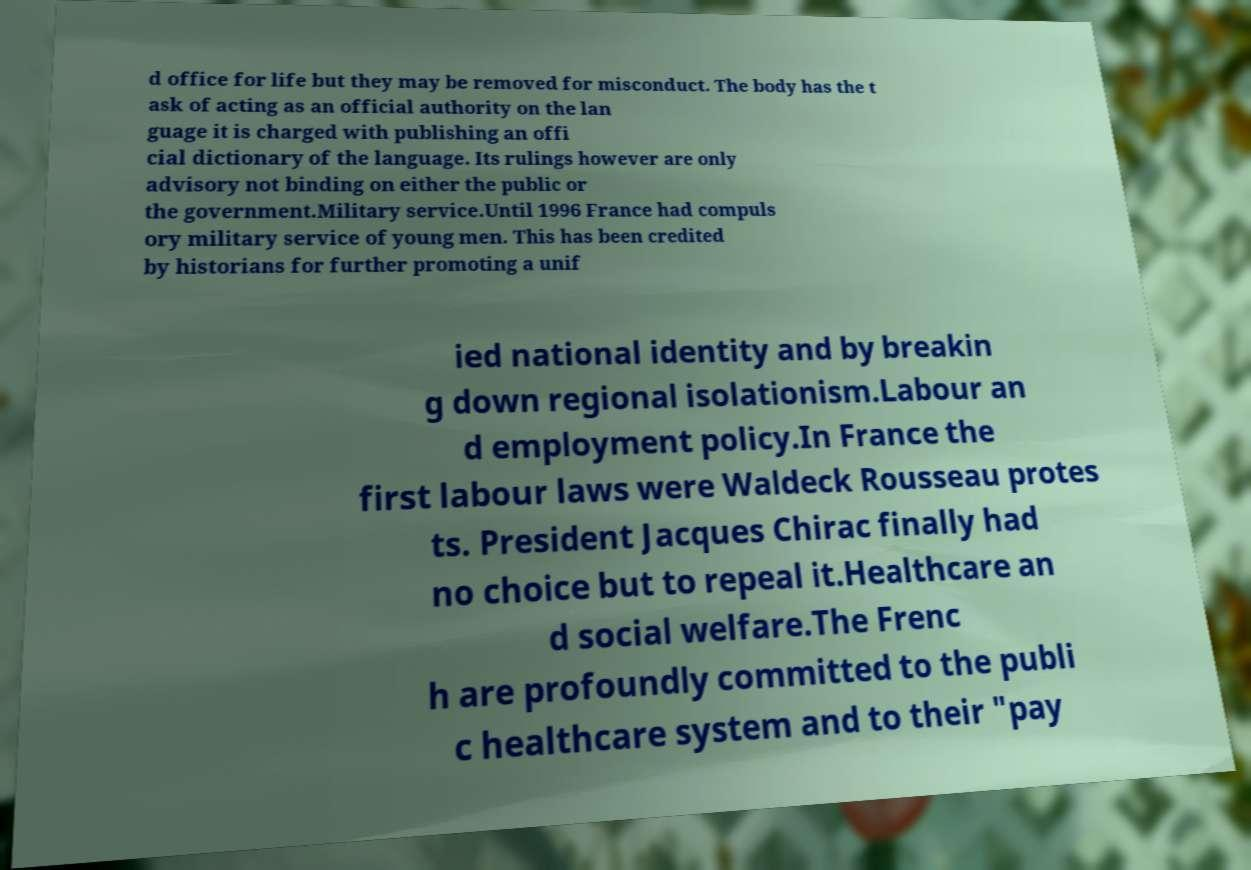Could you extract and type out the text from this image? d office for life but they may be removed for misconduct. The body has the t ask of acting as an official authority on the lan guage it is charged with publishing an offi cial dictionary of the language. Its rulings however are only advisory not binding on either the public or the government.Military service.Until 1996 France had compuls ory military service of young men. This has been credited by historians for further promoting a unif ied national identity and by breakin g down regional isolationism.Labour an d employment policy.In France the first labour laws were Waldeck Rousseau protes ts. President Jacques Chirac finally had no choice but to repeal it.Healthcare an d social welfare.The Frenc h are profoundly committed to the publi c healthcare system and to their "pay 